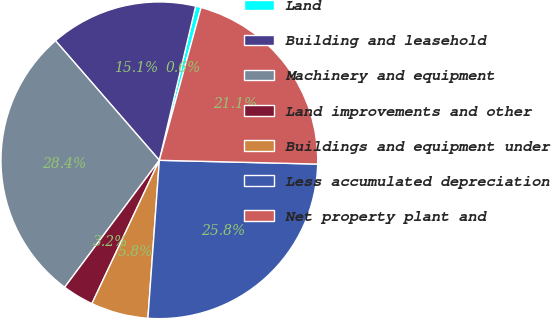Convert chart. <chart><loc_0><loc_0><loc_500><loc_500><pie_chart><fcel>Land<fcel>Building and leasehold<fcel>Machinery and equipment<fcel>Land improvements and other<fcel>Buildings and equipment under<fcel>Less accumulated depreciation<fcel>Net property plant and<nl><fcel>0.56%<fcel>15.06%<fcel>28.42%<fcel>3.2%<fcel>5.85%<fcel>25.77%<fcel>21.14%<nl></chart> 